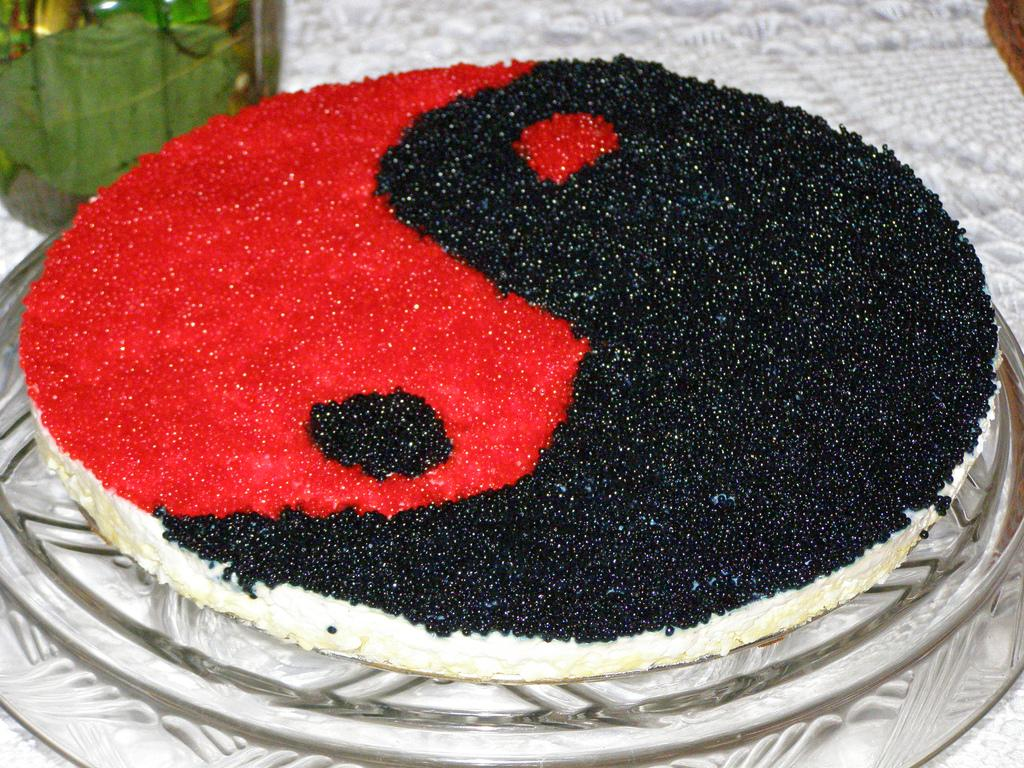What is the main subject of the image? The main subject of the image is a cake on a plate. Can you describe the design on the cake? The cake has a yin-yang print on it. Is there anything else visible in the image besides the cake? Yes, there is an unspecified object in the top left of the image. Can you tell me how many friends are sitting next to the cake in the image? There are no friends visible in the image; it only features a cake on a plate and an unspecified object in the top left. What type of worm can be seen crawling on the cake in the image? There are no worms present on the cake in the image; it has a yin-yang print. 